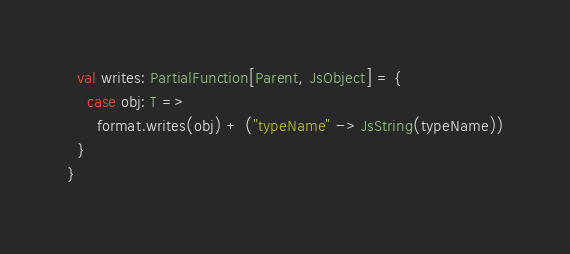Convert code to text. <code><loc_0><loc_0><loc_500><loc_500><_Scala_>  val writes: PartialFunction[Parent, JsObject] = {
    case obj: T =>
      format.writes(obj) + ("typeName" -> JsString(typeName))
  }
}</code> 